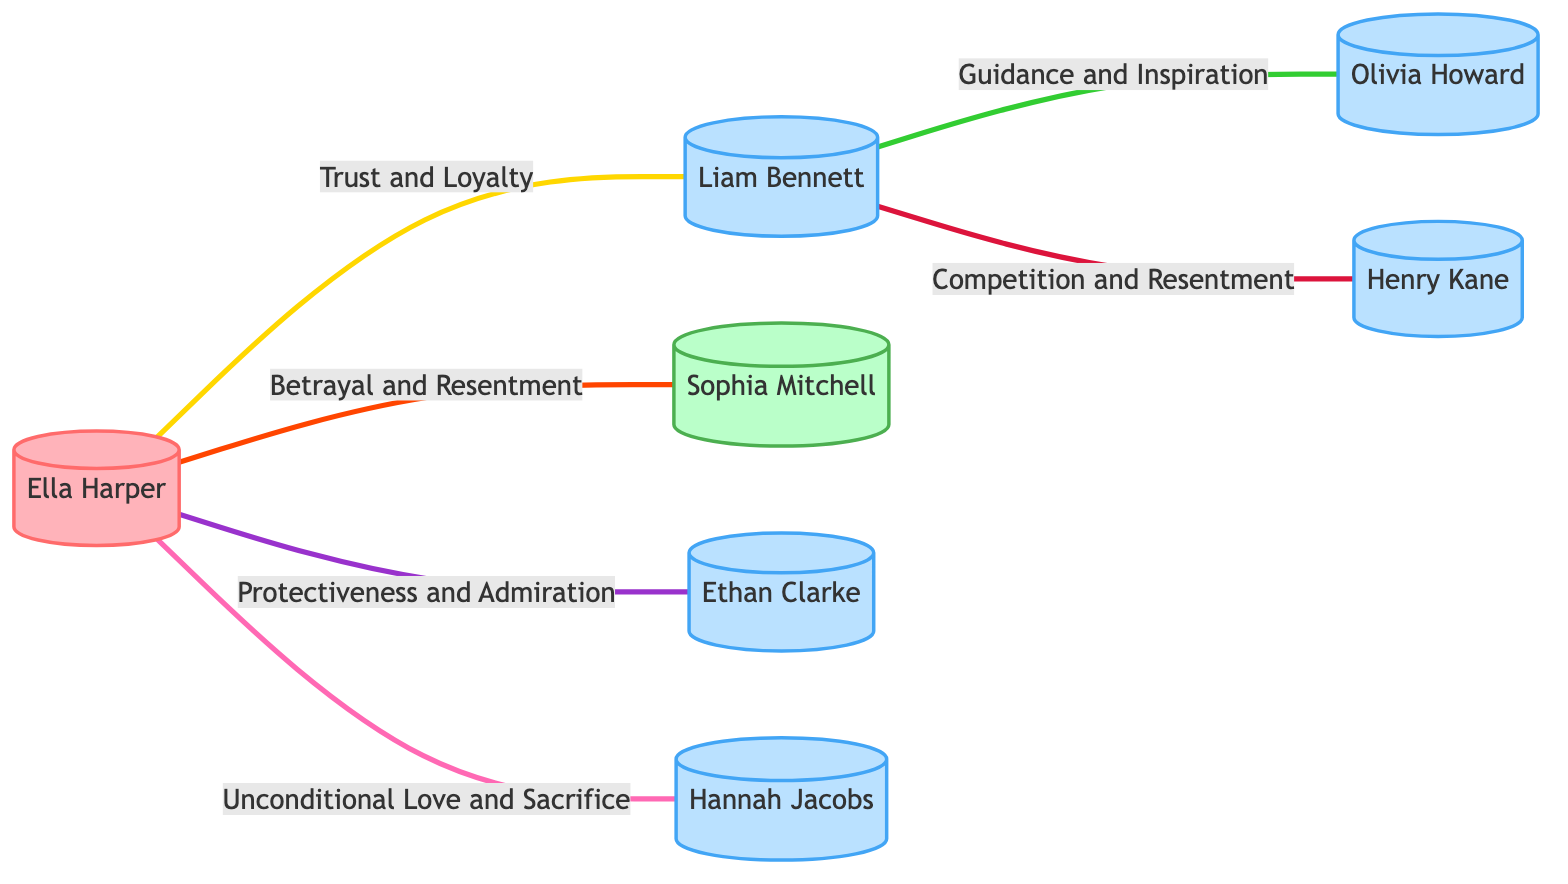What is Ella Harper's role? The diagram specifies that Ella Harper is categorized as the Protagonist.
Answer: Protagonist Who is connected to Liam Bennett by a mentorship relationship? According to the diagram, Olivia Howard is indicated as a Mentor to Liam Bennett.
Answer: Olivia Howard How many characters are directly connected to Ella Harper? By examining the connections in the diagram, Ella Harper is connected to three characters: Liam Bennett, Sophia Mitchell, Ethan Clarke, and Hannah Jacobs.
Answer: Four What type of connection does Ella Harper have with Sophia Mitchell? The relationship type between Ella Harper and Sophia Mitchell is labeled as Ex-Lover in the diagram, which indicates complicity and intensity.
Answer: Ex-Lover What kind of emotional connection does Liam Bennett share with Henry Kane? The diagram illustrates that Liam Bennett has a relationship with Henry Kane characterized by Competition and Resentment.
Answer: Competition and Resentment How many emotional connections involve trust? Upon reviewing the diagram, the emotional connection labeled "Trust and Loyalty" is present between Ella Harper and Liam Bennett, indicating one instance.
Answer: One What describes the emotional connection between Ella Harper and her parent, Hannah Jacobs? The diagram clearly outlines that the emotional connection between Ella Harper and Hannah Jacobs is defined by Unconditional Love and Sacrifice.
Answer: Unconditional Love and Sacrifice Which character feels Betrayal and Resentment from Ella Harper? The diagram points out that the character Sophia Mitchell is associated with Betrayal and Resentment regarding Ella Harper.
Answer: Sophia Mitchell Which character plays the role of Antagonist? In the diagram, Sophia Mitchell is specifically identified as the Antagonist.
Answer: Sophia Mitchell 